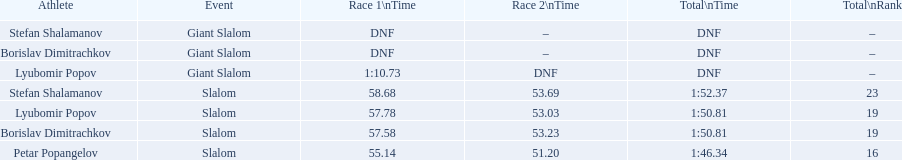Which occasion refers to the giant slalom? Giant Slalom, Giant Slalom, Giant Slalom. Parse the table in full. {'header': ['Athlete', 'Event', 'Race 1\\nTime', 'Race 2\\nTime', 'Total\\nTime', 'Total\\nRank'], 'rows': [['Stefan Shalamanov', 'Giant Slalom', 'DNF', '–', 'DNF', '–'], ['Borislav Dimitrachkov', 'Giant Slalom', 'DNF', '–', 'DNF', '–'], ['Lyubomir Popov', 'Giant Slalom', '1:10.73', 'DNF', 'DNF', '–'], ['Stefan Shalamanov', 'Slalom', '58.68', '53.69', '1:52.37', '23'], ['Lyubomir Popov', 'Slalom', '57.78', '53.03', '1:50.81', '19'], ['Borislav Dimitrachkov', 'Slalom', '57.58', '53.23', '1:50.81', '19'], ['Petar Popangelov', 'Slalom', '55.14', '51.20', '1:46.34', '16']]} Who can be identified as lyubomir popov? Lyubomir Popov. What time does race 1 commence? 1:10.73. 